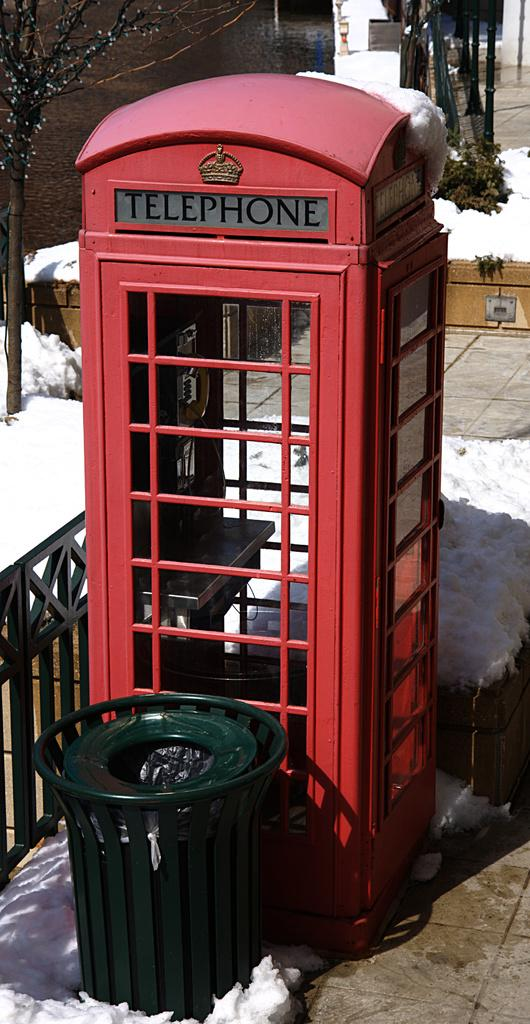<image>
Relay a brief, clear account of the picture shown. A red booth used for making telephone calls is surrounded by snow. 